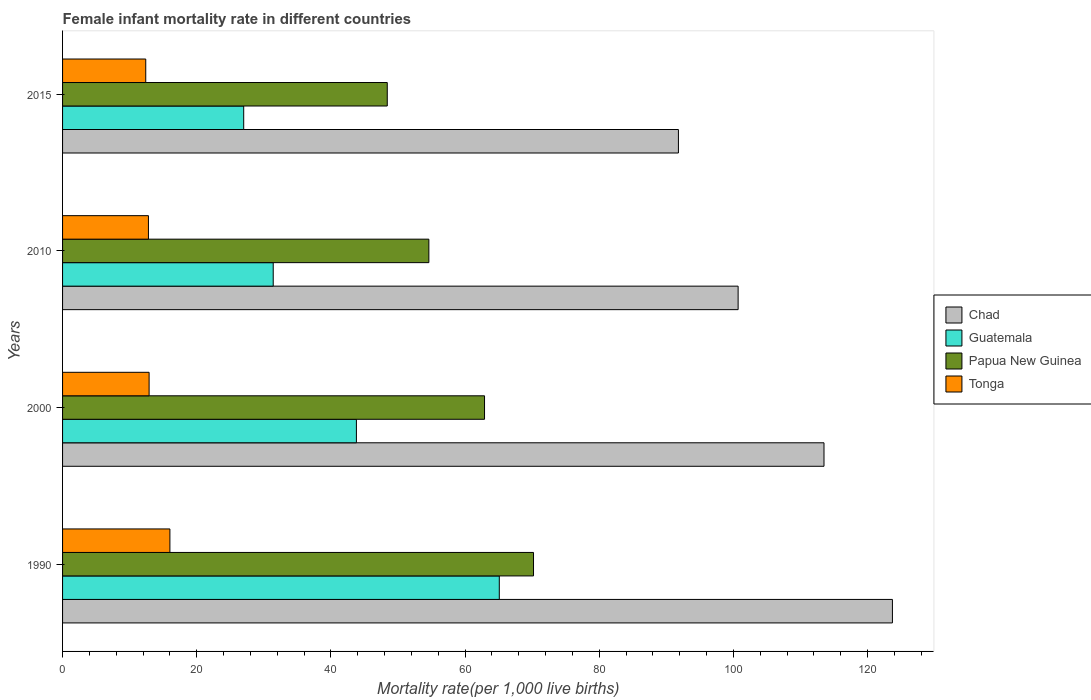How many different coloured bars are there?
Your answer should be very brief. 4. How many groups of bars are there?
Offer a very short reply. 4. Are the number of bars on each tick of the Y-axis equal?
Ensure brevity in your answer.  Yes. How many bars are there on the 1st tick from the top?
Ensure brevity in your answer.  4. How many bars are there on the 3rd tick from the bottom?
Provide a succinct answer. 4. What is the label of the 1st group of bars from the top?
Ensure brevity in your answer.  2015. In how many cases, is the number of bars for a given year not equal to the number of legend labels?
Give a very brief answer. 0. Across all years, what is the maximum female infant mortality rate in Guatemala?
Give a very brief answer. 65.1. Across all years, what is the minimum female infant mortality rate in Guatemala?
Give a very brief answer. 27. In which year was the female infant mortality rate in Chad minimum?
Provide a succinct answer. 2015. What is the total female infant mortality rate in Tonga in the graph?
Your answer should be very brief. 54.1. What is the difference between the female infant mortality rate in Guatemala in 2000 and that in 2010?
Provide a succinct answer. 12.4. What is the difference between the female infant mortality rate in Guatemala in 1990 and the female infant mortality rate in Papua New Guinea in 2015?
Offer a very short reply. 16.7. What is the average female infant mortality rate in Papua New Guinea per year?
Your answer should be very brief. 59.02. In the year 2015, what is the difference between the female infant mortality rate in Guatemala and female infant mortality rate in Papua New Guinea?
Your answer should be very brief. -21.4. In how many years, is the female infant mortality rate in Chad greater than 112 ?
Ensure brevity in your answer.  2. What is the ratio of the female infant mortality rate in Chad in 1990 to that in 2015?
Offer a terse response. 1.35. What is the difference between the highest and the second highest female infant mortality rate in Chad?
Provide a short and direct response. 10.2. What is the difference between the highest and the lowest female infant mortality rate in Chad?
Give a very brief answer. 31.9. Is it the case that in every year, the sum of the female infant mortality rate in Guatemala and female infant mortality rate in Papua New Guinea is greater than the sum of female infant mortality rate in Chad and female infant mortality rate in Tonga?
Keep it short and to the point. No. What does the 3rd bar from the top in 2015 represents?
Ensure brevity in your answer.  Guatemala. What does the 4th bar from the bottom in 2000 represents?
Provide a succinct answer. Tonga. Is it the case that in every year, the sum of the female infant mortality rate in Papua New Guinea and female infant mortality rate in Tonga is greater than the female infant mortality rate in Chad?
Your response must be concise. No. What is the difference between two consecutive major ticks on the X-axis?
Your answer should be very brief. 20. What is the title of the graph?
Keep it short and to the point. Female infant mortality rate in different countries. Does "Costa Rica" appear as one of the legend labels in the graph?
Your answer should be compact. No. What is the label or title of the X-axis?
Offer a terse response. Mortality rate(per 1,0 live births). What is the label or title of the Y-axis?
Provide a short and direct response. Years. What is the Mortality rate(per 1,000 live births) of Chad in 1990?
Offer a terse response. 123.7. What is the Mortality rate(per 1,000 live births) in Guatemala in 1990?
Provide a succinct answer. 65.1. What is the Mortality rate(per 1,000 live births) in Papua New Guinea in 1990?
Offer a terse response. 70.2. What is the Mortality rate(per 1,000 live births) of Tonga in 1990?
Make the answer very short. 16. What is the Mortality rate(per 1,000 live births) in Chad in 2000?
Provide a succinct answer. 113.5. What is the Mortality rate(per 1,000 live births) in Guatemala in 2000?
Your answer should be very brief. 43.8. What is the Mortality rate(per 1,000 live births) in Papua New Guinea in 2000?
Make the answer very short. 62.9. What is the Mortality rate(per 1,000 live births) of Tonga in 2000?
Your answer should be compact. 12.9. What is the Mortality rate(per 1,000 live births) in Chad in 2010?
Your response must be concise. 100.7. What is the Mortality rate(per 1,000 live births) of Guatemala in 2010?
Offer a terse response. 31.4. What is the Mortality rate(per 1,000 live births) of Papua New Guinea in 2010?
Offer a terse response. 54.6. What is the Mortality rate(per 1,000 live births) in Tonga in 2010?
Keep it short and to the point. 12.8. What is the Mortality rate(per 1,000 live births) in Chad in 2015?
Offer a terse response. 91.8. What is the Mortality rate(per 1,000 live births) in Papua New Guinea in 2015?
Your response must be concise. 48.4. What is the Mortality rate(per 1,000 live births) of Tonga in 2015?
Make the answer very short. 12.4. Across all years, what is the maximum Mortality rate(per 1,000 live births) in Chad?
Your response must be concise. 123.7. Across all years, what is the maximum Mortality rate(per 1,000 live births) of Guatemala?
Provide a succinct answer. 65.1. Across all years, what is the maximum Mortality rate(per 1,000 live births) of Papua New Guinea?
Provide a short and direct response. 70.2. Across all years, what is the maximum Mortality rate(per 1,000 live births) of Tonga?
Ensure brevity in your answer.  16. Across all years, what is the minimum Mortality rate(per 1,000 live births) of Chad?
Offer a very short reply. 91.8. Across all years, what is the minimum Mortality rate(per 1,000 live births) of Guatemala?
Provide a succinct answer. 27. Across all years, what is the minimum Mortality rate(per 1,000 live births) of Papua New Guinea?
Give a very brief answer. 48.4. Across all years, what is the minimum Mortality rate(per 1,000 live births) of Tonga?
Provide a short and direct response. 12.4. What is the total Mortality rate(per 1,000 live births) in Chad in the graph?
Provide a short and direct response. 429.7. What is the total Mortality rate(per 1,000 live births) of Guatemala in the graph?
Provide a succinct answer. 167.3. What is the total Mortality rate(per 1,000 live births) in Papua New Guinea in the graph?
Your response must be concise. 236.1. What is the total Mortality rate(per 1,000 live births) in Tonga in the graph?
Keep it short and to the point. 54.1. What is the difference between the Mortality rate(per 1,000 live births) in Guatemala in 1990 and that in 2000?
Provide a short and direct response. 21.3. What is the difference between the Mortality rate(per 1,000 live births) in Guatemala in 1990 and that in 2010?
Give a very brief answer. 33.7. What is the difference between the Mortality rate(per 1,000 live births) in Papua New Guinea in 1990 and that in 2010?
Your answer should be very brief. 15.6. What is the difference between the Mortality rate(per 1,000 live births) of Chad in 1990 and that in 2015?
Offer a very short reply. 31.9. What is the difference between the Mortality rate(per 1,000 live births) in Guatemala in 1990 and that in 2015?
Provide a short and direct response. 38.1. What is the difference between the Mortality rate(per 1,000 live births) in Papua New Guinea in 1990 and that in 2015?
Your answer should be very brief. 21.8. What is the difference between the Mortality rate(per 1,000 live births) in Tonga in 1990 and that in 2015?
Offer a very short reply. 3.6. What is the difference between the Mortality rate(per 1,000 live births) of Papua New Guinea in 2000 and that in 2010?
Offer a terse response. 8.3. What is the difference between the Mortality rate(per 1,000 live births) in Tonga in 2000 and that in 2010?
Keep it short and to the point. 0.1. What is the difference between the Mortality rate(per 1,000 live births) in Chad in 2000 and that in 2015?
Your answer should be compact. 21.7. What is the difference between the Mortality rate(per 1,000 live births) in Papua New Guinea in 2000 and that in 2015?
Give a very brief answer. 14.5. What is the difference between the Mortality rate(per 1,000 live births) in Tonga in 2000 and that in 2015?
Your answer should be compact. 0.5. What is the difference between the Mortality rate(per 1,000 live births) in Papua New Guinea in 2010 and that in 2015?
Offer a terse response. 6.2. What is the difference between the Mortality rate(per 1,000 live births) of Chad in 1990 and the Mortality rate(per 1,000 live births) of Guatemala in 2000?
Ensure brevity in your answer.  79.9. What is the difference between the Mortality rate(per 1,000 live births) in Chad in 1990 and the Mortality rate(per 1,000 live births) in Papua New Guinea in 2000?
Your answer should be very brief. 60.8. What is the difference between the Mortality rate(per 1,000 live births) of Chad in 1990 and the Mortality rate(per 1,000 live births) of Tonga in 2000?
Offer a very short reply. 110.8. What is the difference between the Mortality rate(per 1,000 live births) of Guatemala in 1990 and the Mortality rate(per 1,000 live births) of Papua New Guinea in 2000?
Keep it short and to the point. 2.2. What is the difference between the Mortality rate(per 1,000 live births) in Guatemala in 1990 and the Mortality rate(per 1,000 live births) in Tonga in 2000?
Provide a short and direct response. 52.2. What is the difference between the Mortality rate(per 1,000 live births) in Papua New Guinea in 1990 and the Mortality rate(per 1,000 live births) in Tonga in 2000?
Keep it short and to the point. 57.3. What is the difference between the Mortality rate(per 1,000 live births) in Chad in 1990 and the Mortality rate(per 1,000 live births) in Guatemala in 2010?
Offer a terse response. 92.3. What is the difference between the Mortality rate(per 1,000 live births) in Chad in 1990 and the Mortality rate(per 1,000 live births) in Papua New Guinea in 2010?
Keep it short and to the point. 69.1. What is the difference between the Mortality rate(per 1,000 live births) of Chad in 1990 and the Mortality rate(per 1,000 live births) of Tonga in 2010?
Make the answer very short. 110.9. What is the difference between the Mortality rate(per 1,000 live births) in Guatemala in 1990 and the Mortality rate(per 1,000 live births) in Papua New Guinea in 2010?
Keep it short and to the point. 10.5. What is the difference between the Mortality rate(per 1,000 live births) of Guatemala in 1990 and the Mortality rate(per 1,000 live births) of Tonga in 2010?
Ensure brevity in your answer.  52.3. What is the difference between the Mortality rate(per 1,000 live births) of Papua New Guinea in 1990 and the Mortality rate(per 1,000 live births) of Tonga in 2010?
Provide a succinct answer. 57.4. What is the difference between the Mortality rate(per 1,000 live births) of Chad in 1990 and the Mortality rate(per 1,000 live births) of Guatemala in 2015?
Offer a very short reply. 96.7. What is the difference between the Mortality rate(per 1,000 live births) of Chad in 1990 and the Mortality rate(per 1,000 live births) of Papua New Guinea in 2015?
Your answer should be very brief. 75.3. What is the difference between the Mortality rate(per 1,000 live births) in Chad in 1990 and the Mortality rate(per 1,000 live births) in Tonga in 2015?
Keep it short and to the point. 111.3. What is the difference between the Mortality rate(per 1,000 live births) in Guatemala in 1990 and the Mortality rate(per 1,000 live births) in Papua New Guinea in 2015?
Provide a succinct answer. 16.7. What is the difference between the Mortality rate(per 1,000 live births) of Guatemala in 1990 and the Mortality rate(per 1,000 live births) of Tonga in 2015?
Make the answer very short. 52.7. What is the difference between the Mortality rate(per 1,000 live births) of Papua New Guinea in 1990 and the Mortality rate(per 1,000 live births) of Tonga in 2015?
Keep it short and to the point. 57.8. What is the difference between the Mortality rate(per 1,000 live births) of Chad in 2000 and the Mortality rate(per 1,000 live births) of Guatemala in 2010?
Your response must be concise. 82.1. What is the difference between the Mortality rate(per 1,000 live births) in Chad in 2000 and the Mortality rate(per 1,000 live births) in Papua New Guinea in 2010?
Give a very brief answer. 58.9. What is the difference between the Mortality rate(per 1,000 live births) of Chad in 2000 and the Mortality rate(per 1,000 live births) of Tonga in 2010?
Provide a succinct answer. 100.7. What is the difference between the Mortality rate(per 1,000 live births) in Papua New Guinea in 2000 and the Mortality rate(per 1,000 live births) in Tonga in 2010?
Provide a succinct answer. 50.1. What is the difference between the Mortality rate(per 1,000 live births) of Chad in 2000 and the Mortality rate(per 1,000 live births) of Guatemala in 2015?
Ensure brevity in your answer.  86.5. What is the difference between the Mortality rate(per 1,000 live births) of Chad in 2000 and the Mortality rate(per 1,000 live births) of Papua New Guinea in 2015?
Ensure brevity in your answer.  65.1. What is the difference between the Mortality rate(per 1,000 live births) of Chad in 2000 and the Mortality rate(per 1,000 live births) of Tonga in 2015?
Offer a very short reply. 101.1. What is the difference between the Mortality rate(per 1,000 live births) in Guatemala in 2000 and the Mortality rate(per 1,000 live births) in Papua New Guinea in 2015?
Your answer should be very brief. -4.6. What is the difference between the Mortality rate(per 1,000 live births) of Guatemala in 2000 and the Mortality rate(per 1,000 live births) of Tonga in 2015?
Offer a very short reply. 31.4. What is the difference between the Mortality rate(per 1,000 live births) of Papua New Guinea in 2000 and the Mortality rate(per 1,000 live births) of Tonga in 2015?
Provide a succinct answer. 50.5. What is the difference between the Mortality rate(per 1,000 live births) of Chad in 2010 and the Mortality rate(per 1,000 live births) of Guatemala in 2015?
Provide a succinct answer. 73.7. What is the difference between the Mortality rate(per 1,000 live births) of Chad in 2010 and the Mortality rate(per 1,000 live births) of Papua New Guinea in 2015?
Provide a short and direct response. 52.3. What is the difference between the Mortality rate(per 1,000 live births) of Chad in 2010 and the Mortality rate(per 1,000 live births) of Tonga in 2015?
Provide a succinct answer. 88.3. What is the difference between the Mortality rate(per 1,000 live births) in Guatemala in 2010 and the Mortality rate(per 1,000 live births) in Papua New Guinea in 2015?
Provide a succinct answer. -17. What is the difference between the Mortality rate(per 1,000 live births) of Guatemala in 2010 and the Mortality rate(per 1,000 live births) of Tonga in 2015?
Make the answer very short. 19. What is the difference between the Mortality rate(per 1,000 live births) in Papua New Guinea in 2010 and the Mortality rate(per 1,000 live births) in Tonga in 2015?
Your answer should be compact. 42.2. What is the average Mortality rate(per 1,000 live births) in Chad per year?
Give a very brief answer. 107.42. What is the average Mortality rate(per 1,000 live births) in Guatemala per year?
Keep it short and to the point. 41.83. What is the average Mortality rate(per 1,000 live births) in Papua New Guinea per year?
Provide a succinct answer. 59.02. What is the average Mortality rate(per 1,000 live births) of Tonga per year?
Ensure brevity in your answer.  13.53. In the year 1990, what is the difference between the Mortality rate(per 1,000 live births) of Chad and Mortality rate(per 1,000 live births) of Guatemala?
Make the answer very short. 58.6. In the year 1990, what is the difference between the Mortality rate(per 1,000 live births) of Chad and Mortality rate(per 1,000 live births) of Papua New Guinea?
Provide a short and direct response. 53.5. In the year 1990, what is the difference between the Mortality rate(per 1,000 live births) of Chad and Mortality rate(per 1,000 live births) of Tonga?
Ensure brevity in your answer.  107.7. In the year 1990, what is the difference between the Mortality rate(per 1,000 live births) of Guatemala and Mortality rate(per 1,000 live births) of Tonga?
Give a very brief answer. 49.1. In the year 1990, what is the difference between the Mortality rate(per 1,000 live births) in Papua New Guinea and Mortality rate(per 1,000 live births) in Tonga?
Your answer should be compact. 54.2. In the year 2000, what is the difference between the Mortality rate(per 1,000 live births) of Chad and Mortality rate(per 1,000 live births) of Guatemala?
Offer a very short reply. 69.7. In the year 2000, what is the difference between the Mortality rate(per 1,000 live births) of Chad and Mortality rate(per 1,000 live births) of Papua New Guinea?
Your answer should be compact. 50.6. In the year 2000, what is the difference between the Mortality rate(per 1,000 live births) in Chad and Mortality rate(per 1,000 live births) in Tonga?
Provide a short and direct response. 100.6. In the year 2000, what is the difference between the Mortality rate(per 1,000 live births) in Guatemala and Mortality rate(per 1,000 live births) in Papua New Guinea?
Your answer should be compact. -19.1. In the year 2000, what is the difference between the Mortality rate(per 1,000 live births) of Guatemala and Mortality rate(per 1,000 live births) of Tonga?
Offer a terse response. 30.9. In the year 2000, what is the difference between the Mortality rate(per 1,000 live births) in Papua New Guinea and Mortality rate(per 1,000 live births) in Tonga?
Make the answer very short. 50. In the year 2010, what is the difference between the Mortality rate(per 1,000 live births) of Chad and Mortality rate(per 1,000 live births) of Guatemala?
Offer a terse response. 69.3. In the year 2010, what is the difference between the Mortality rate(per 1,000 live births) of Chad and Mortality rate(per 1,000 live births) of Papua New Guinea?
Make the answer very short. 46.1. In the year 2010, what is the difference between the Mortality rate(per 1,000 live births) of Chad and Mortality rate(per 1,000 live births) of Tonga?
Give a very brief answer. 87.9. In the year 2010, what is the difference between the Mortality rate(per 1,000 live births) of Guatemala and Mortality rate(per 1,000 live births) of Papua New Guinea?
Provide a short and direct response. -23.2. In the year 2010, what is the difference between the Mortality rate(per 1,000 live births) of Guatemala and Mortality rate(per 1,000 live births) of Tonga?
Keep it short and to the point. 18.6. In the year 2010, what is the difference between the Mortality rate(per 1,000 live births) in Papua New Guinea and Mortality rate(per 1,000 live births) in Tonga?
Your response must be concise. 41.8. In the year 2015, what is the difference between the Mortality rate(per 1,000 live births) in Chad and Mortality rate(per 1,000 live births) in Guatemala?
Give a very brief answer. 64.8. In the year 2015, what is the difference between the Mortality rate(per 1,000 live births) of Chad and Mortality rate(per 1,000 live births) of Papua New Guinea?
Your answer should be compact. 43.4. In the year 2015, what is the difference between the Mortality rate(per 1,000 live births) in Chad and Mortality rate(per 1,000 live births) in Tonga?
Give a very brief answer. 79.4. In the year 2015, what is the difference between the Mortality rate(per 1,000 live births) in Guatemala and Mortality rate(per 1,000 live births) in Papua New Guinea?
Provide a short and direct response. -21.4. In the year 2015, what is the difference between the Mortality rate(per 1,000 live births) in Papua New Guinea and Mortality rate(per 1,000 live births) in Tonga?
Give a very brief answer. 36. What is the ratio of the Mortality rate(per 1,000 live births) of Chad in 1990 to that in 2000?
Give a very brief answer. 1.09. What is the ratio of the Mortality rate(per 1,000 live births) of Guatemala in 1990 to that in 2000?
Offer a very short reply. 1.49. What is the ratio of the Mortality rate(per 1,000 live births) in Papua New Guinea in 1990 to that in 2000?
Your response must be concise. 1.12. What is the ratio of the Mortality rate(per 1,000 live births) in Tonga in 1990 to that in 2000?
Give a very brief answer. 1.24. What is the ratio of the Mortality rate(per 1,000 live births) in Chad in 1990 to that in 2010?
Make the answer very short. 1.23. What is the ratio of the Mortality rate(per 1,000 live births) of Guatemala in 1990 to that in 2010?
Provide a succinct answer. 2.07. What is the ratio of the Mortality rate(per 1,000 live births) in Chad in 1990 to that in 2015?
Your answer should be very brief. 1.35. What is the ratio of the Mortality rate(per 1,000 live births) in Guatemala in 1990 to that in 2015?
Provide a short and direct response. 2.41. What is the ratio of the Mortality rate(per 1,000 live births) in Papua New Guinea in 1990 to that in 2015?
Give a very brief answer. 1.45. What is the ratio of the Mortality rate(per 1,000 live births) in Tonga in 1990 to that in 2015?
Make the answer very short. 1.29. What is the ratio of the Mortality rate(per 1,000 live births) of Chad in 2000 to that in 2010?
Your answer should be compact. 1.13. What is the ratio of the Mortality rate(per 1,000 live births) in Guatemala in 2000 to that in 2010?
Provide a succinct answer. 1.39. What is the ratio of the Mortality rate(per 1,000 live births) of Papua New Guinea in 2000 to that in 2010?
Make the answer very short. 1.15. What is the ratio of the Mortality rate(per 1,000 live births) of Tonga in 2000 to that in 2010?
Provide a short and direct response. 1.01. What is the ratio of the Mortality rate(per 1,000 live births) in Chad in 2000 to that in 2015?
Your answer should be compact. 1.24. What is the ratio of the Mortality rate(per 1,000 live births) in Guatemala in 2000 to that in 2015?
Offer a very short reply. 1.62. What is the ratio of the Mortality rate(per 1,000 live births) in Papua New Guinea in 2000 to that in 2015?
Your answer should be very brief. 1.3. What is the ratio of the Mortality rate(per 1,000 live births) in Tonga in 2000 to that in 2015?
Offer a terse response. 1.04. What is the ratio of the Mortality rate(per 1,000 live births) of Chad in 2010 to that in 2015?
Provide a succinct answer. 1.1. What is the ratio of the Mortality rate(per 1,000 live births) in Guatemala in 2010 to that in 2015?
Provide a succinct answer. 1.16. What is the ratio of the Mortality rate(per 1,000 live births) in Papua New Guinea in 2010 to that in 2015?
Your response must be concise. 1.13. What is the ratio of the Mortality rate(per 1,000 live births) in Tonga in 2010 to that in 2015?
Your answer should be very brief. 1.03. What is the difference between the highest and the second highest Mortality rate(per 1,000 live births) in Chad?
Give a very brief answer. 10.2. What is the difference between the highest and the second highest Mortality rate(per 1,000 live births) in Guatemala?
Provide a succinct answer. 21.3. What is the difference between the highest and the second highest Mortality rate(per 1,000 live births) of Papua New Guinea?
Provide a short and direct response. 7.3. What is the difference between the highest and the lowest Mortality rate(per 1,000 live births) of Chad?
Offer a very short reply. 31.9. What is the difference between the highest and the lowest Mortality rate(per 1,000 live births) of Guatemala?
Provide a succinct answer. 38.1. What is the difference between the highest and the lowest Mortality rate(per 1,000 live births) in Papua New Guinea?
Your response must be concise. 21.8. What is the difference between the highest and the lowest Mortality rate(per 1,000 live births) in Tonga?
Provide a succinct answer. 3.6. 